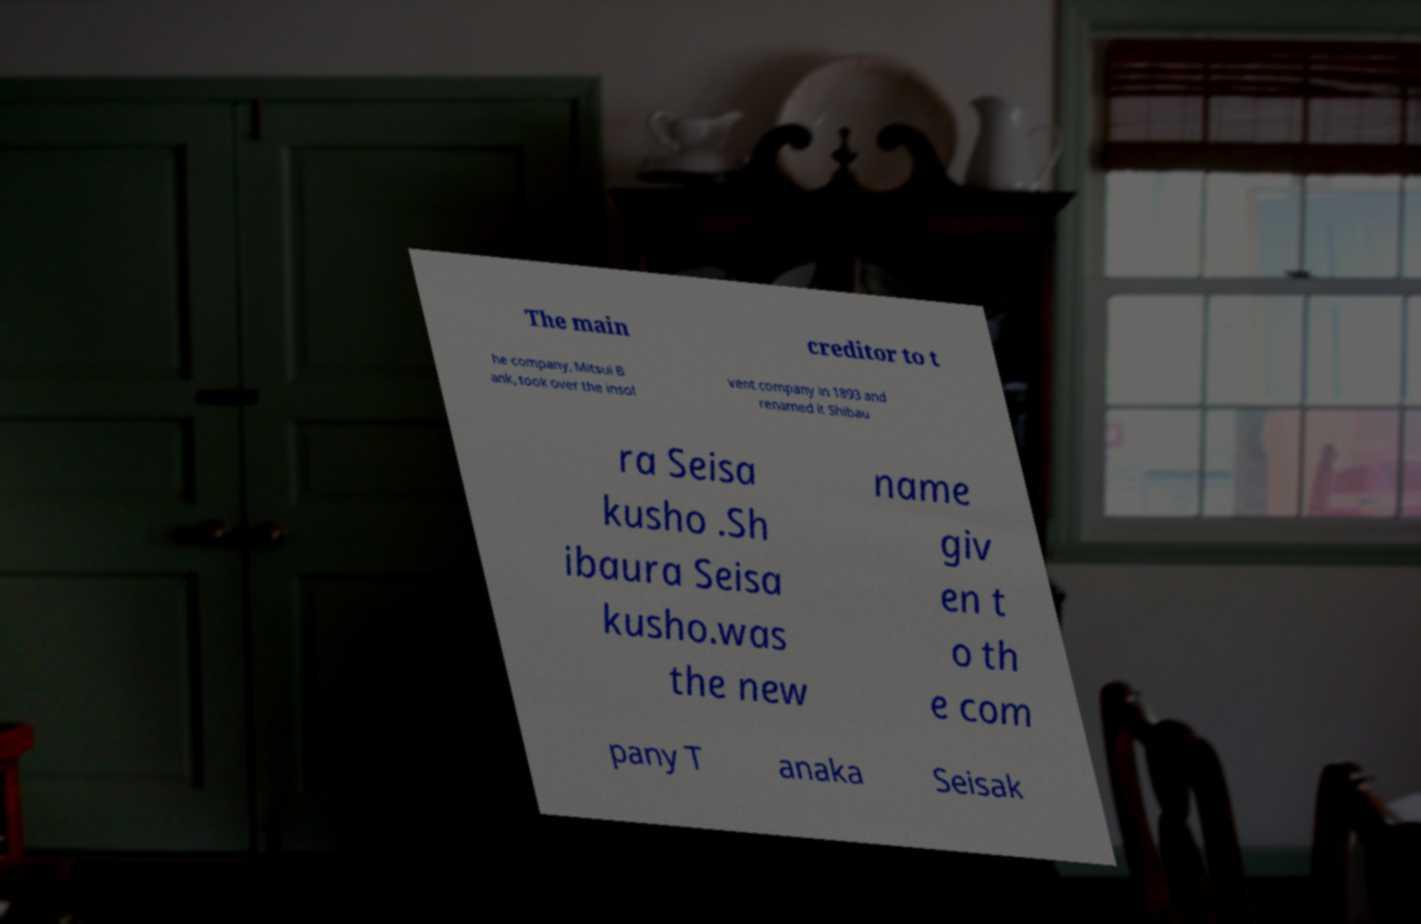Could you assist in decoding the text presented in this image and type it out clearly? The main creditor to t he company, Mitsui B ank, took over the insol vent company in 1893 and renamed it Shibau ra Seisa kusho .Sh ibaura Seisa kusho.was the new name giv en t o th e com pany T anaka Seisak 